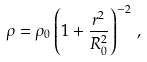<formula> <loc_0><loc_0><loc_500><loc_500>\rho = \rho _ { 0 } \left ( 1 + \frac { r ^ { 2 } } { R _ { 0 } ^ { 2 } } \right ) ^ { - 2 } \, ,</formula> 